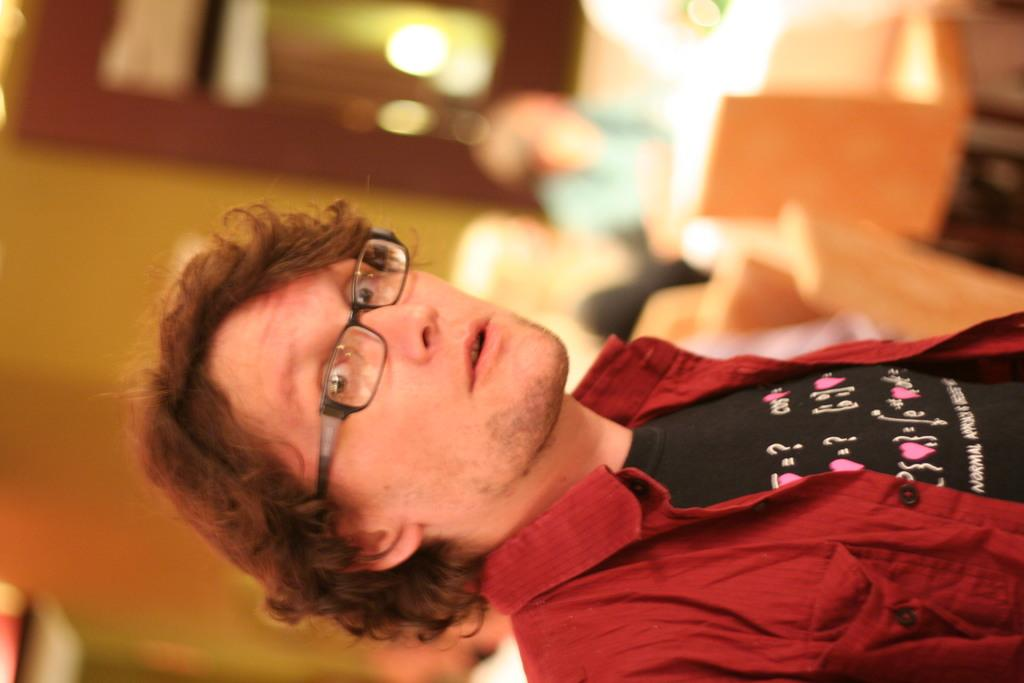Who is the main subject in the image? There is a man in the image. What is the man wearing in the image? The man is wearing glasses in the image. What is the man's posture in the image? The man is standing in the image. Can you describe the background of the image? The background of the image is blurred. Reasoning: Let's think step by step by following these steps to produce the conversation. We start by identifying the main subject in the image, which is the man. Then, we describe the man's appearance and posture, focusing on the glasses and his standing position. Finally, we mention the background of the image, noting that it is blurred. Each question is designed to elicit a specific detail about the image that is known from the provided facts. Absurd Question/Answer: What is the level of pollution in the society depicted in the image? There is no information about pollution or society in the image, as it only features a man standing with glasses and a blurred background. 